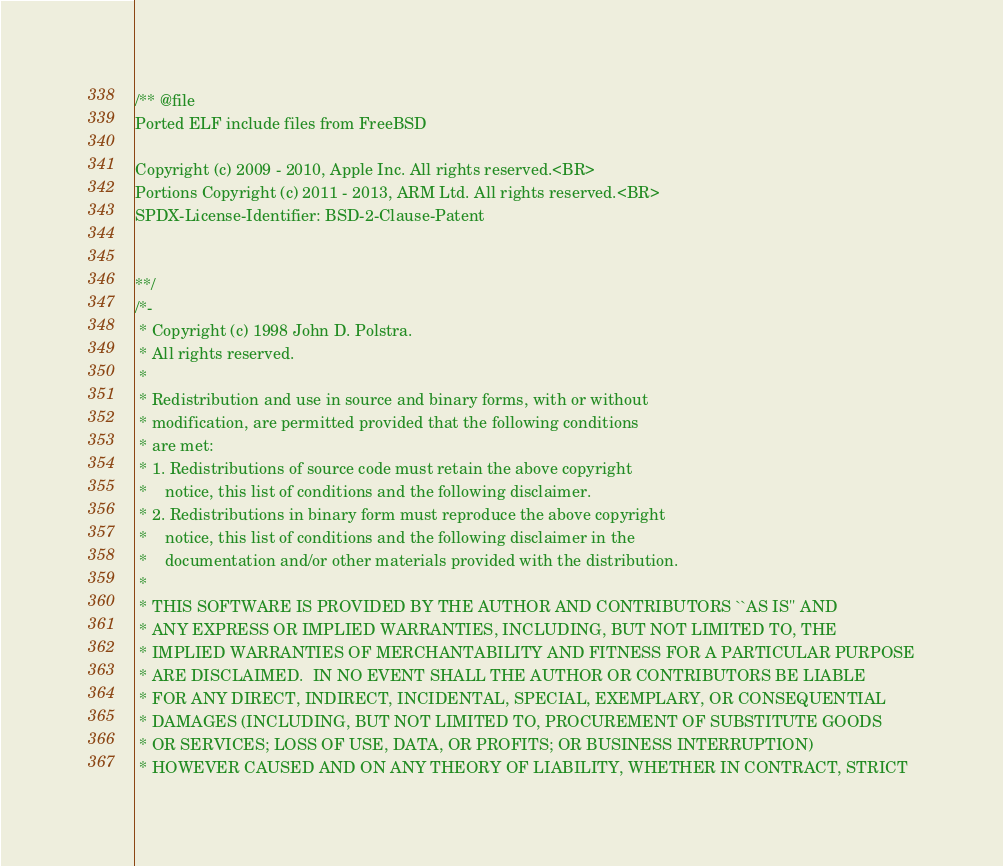Convert code to text. <code><loc_0><loc_0><loc_500><loc_500><_C_>/** @file
Ported ELF include files from FreeBSD

Copyright (c) 2009 - 2010, Apple Inc. All rights reserved.<BR>
Portions Copyright (c) 2011 - 2013, ARM Ltd. All rights reserved.<BR>
SPDX-License-Identifier: BSD-2-Clause-Patent


**/
/*-
 * Copyright (c) 1998 John D. Polstra.
 * All rights reserved.
 *
 * Redistribution and use in source and binary forms, with or without
 * modification, are permitted provided that the following conditions
 * are met:
 * 1. Redistributions of source code must retain the above copyright
 *    notice, this list of conditions and the following disclaimer.
 * 2. Redistributions in binary form must reproduce the above copyright
 *    notice, this list of conditions and the following disclaimer in the
 *    documentation and/or other materials provided with the distribution.
 *
 * THIS SOFTWARE IS PROVIDED BY THE AUTHOR AND CONTRIBUTORS ``AS IS'' AND
 * ANY EXPRESS OR IMPLIED WARRANTIES, INCLUDING, BUT NOT LIMITED TO, THE
 * IMPLIED WARRANTIES OF MERCHANTABILITY AND FITNESS FOR A PARTICULAR PURPOSE
 * ARE DISCLAIMED.  IN NO EVENT SHALL THE AUTHOR OR CONTRIBUTORS BE LIABLE
 * FOR ANY DIRECT, INDIRECT, INCIDENTAL, SPECIAL, EXEMPLARY, OR CONSEQUENTIAL
 * DAMAGES (INCLUDING, BUT NOT LIMITED TO, PROCUREMENT OF SUBSTITUTE GOODS
 * OR SERVICES; LOSS OF USE, DATA, OR PROFITS; OR BUSINESS INTERRUPTION)
 * HOWEVER CAUSED AND ON ANY THEORY OF LIABILITY, WHETHER IN CONTRACT, STRICT</code> 